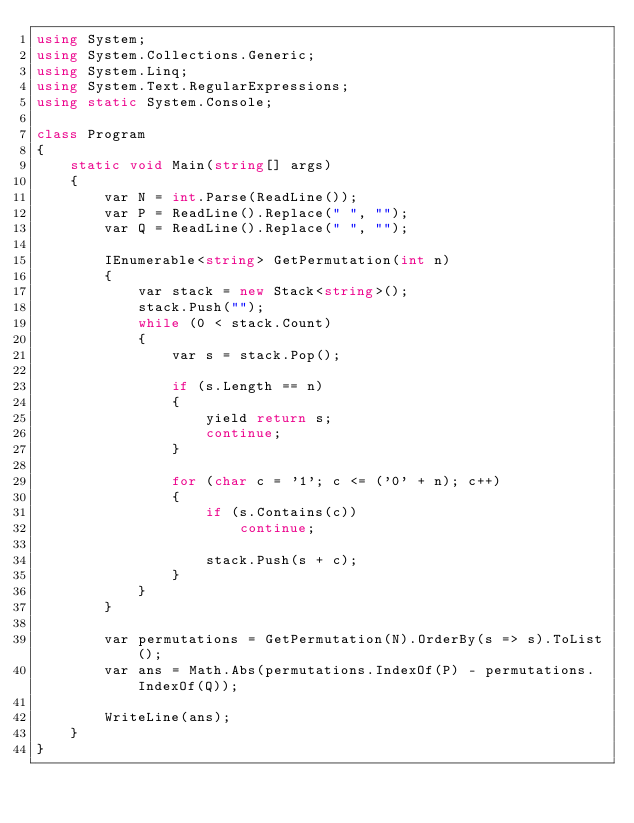Convert code to text. <code><loc_0><loc_0><loc_500><loc_500><_C#_>using System;
using System.Collections.Generic;
using System.Linq;
using System.Text.RegularExpressions;
using static System.Console;

class Program
{
    static void Main(string[] args)
    {
        var N = int.Parse(ReadLine());
        var P = ReadLine().Replace(" ", "");
        var Q = ReadLine().Replace(" ", "");

        IEnumerable<string> GetPermutation(int n)
        {
            var stack = new Stack<string>();
            stack.Push("");
            while (0 < stack.Count)
            {
                var s = stack.Pop();

                if (s.Length == n)
                {
                    yield return s;
                    continue;
                }

                for (char c = '1'; c <= ('0' + n); c++)
                {
                    if (s.Contains(c))
                        continue;

                    stack.Push(s + c);
                }
            }
        }

        var permutations = GetPermutation(N).OrderBy(s => s).ToList();
        var ans = Math.Abs(permutations.IndexOf(P) - permutations.IndexOf(Q));

        WriteLine(ans);
    }
}
</code> 